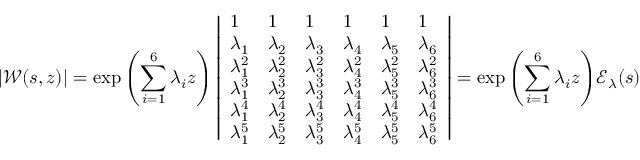Convert formula to latex. <formula><loc_0><loc_0><loc_500><loc_500>| \ m a t h s c r { W } ( s , z ) | = \exp { \left ( \sum _ { i = 1 } ^ { 6 } \lambda _ { i } z \right ) } \left | \begin{array} { l l l l l l } { 1 } & { 1 } & { 1 } & { 1 } & { 1 } & { 1 } \\ { \lambda _ { 1 } } & { \lambda _ { 2 } } & { \lambda _ { 3 } } & { \lambda _ { 4 } } & { \lambda _ { 5 } } & { \lambda _ { 6 } } \\ { \lambda _ { 1 } ^ { 2 } } & { \lambda _ { 2 } ^ { 2 } } & { \lambda _ { 3 } ^ { 2 } } & { \lambda _ { 4 } ^ { 2 } } & { \lambda _ { 5 } ^ { 2 } } & { \lambda _ { 6 } ^ { 2 } } \\ { \lambda _ { 1 } ^ { 3 } } & { \lambda _ { 2 } ^ { 3 } } & { \lambda _ { 3 } ^ { 3 } } & { \lambda _ { 4 } ^ { 3 } } & { \lambda _ { 5 } ^ { 3 } } & { \lambda _ { 6 } ^ { 3 } } \\ { \lambda _ { 1 } ^ { 4 } } & { \lambda _ { 2 } ^ { 4 } } & { \lambda _ { 3 } ^ { 4 } } & { \lambda _ { 4 } ^ { 4 } } & { \lambda _ { 5 } ^ { 4 } } & { \lambda _ { 6 } ^ { 4 } } \\ { \lambda _ { 1 } ^ { 5 } } & { \lambda _ { 2 } ^ { 5 } } & { \lambda _ { 3 } ^ { 5 } } & { \lambda _ { 4 } ^ { 5 } } & { \lambda _ { 5 } ^ { 5 } } & { \lambda _ { 6 } ^ { 5 } } \end{array} \right | = \exp { \left ( \sum _ { i = 1 } ^ { 6 } \lambda _ { i } z \right ) } \ m a t h s c r { E } _ { \lambda } ( s )</formula> 